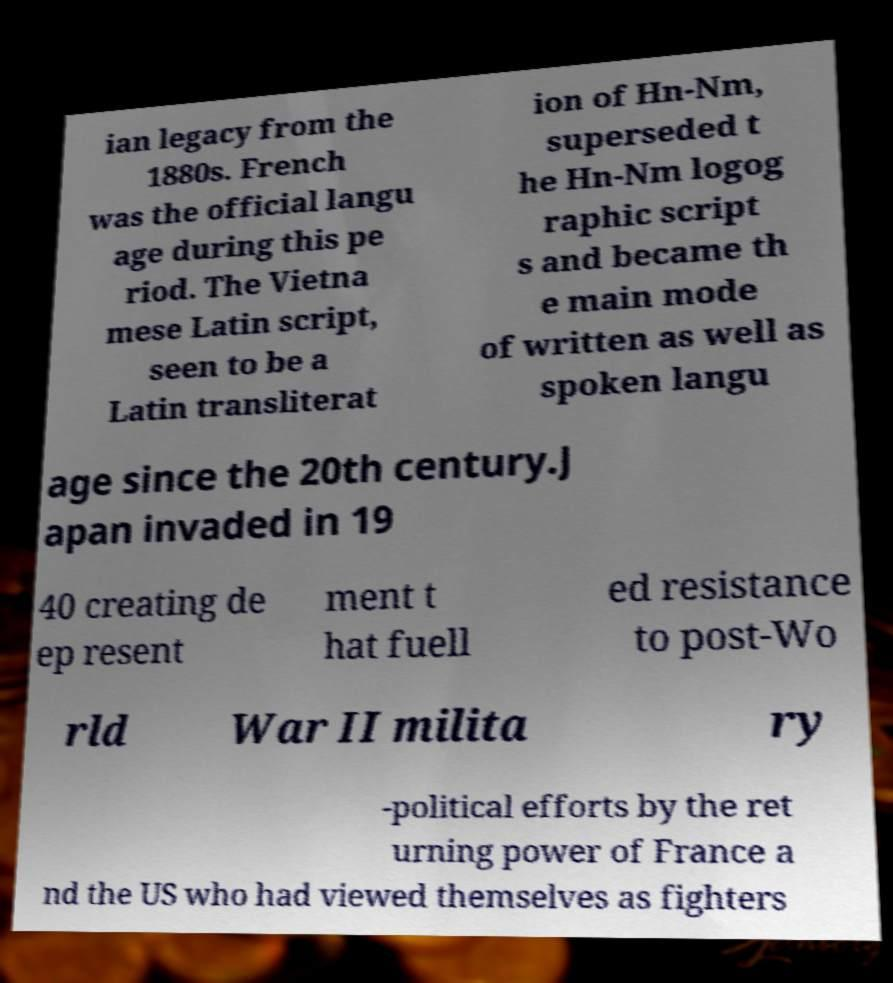Please read and relay the text visible in this image. What does it say? ian legacy from the 1880s. French was the official langu age during this pe riod. The Vietna mese Latin script, seen to be a Latin transliterat ion of Hn-Nm, superseded t he Hn-Nm logog raphic script s and became th e main mode of written as well as spoken langu age since the 20th century.J apan invaded in 19 40 creating de ep resent ment t hat fuell ed resistance to post-Wo rld War II milita ry -political efforts by the ret urning power of France a nd the US who had viewed themselves as fighters 